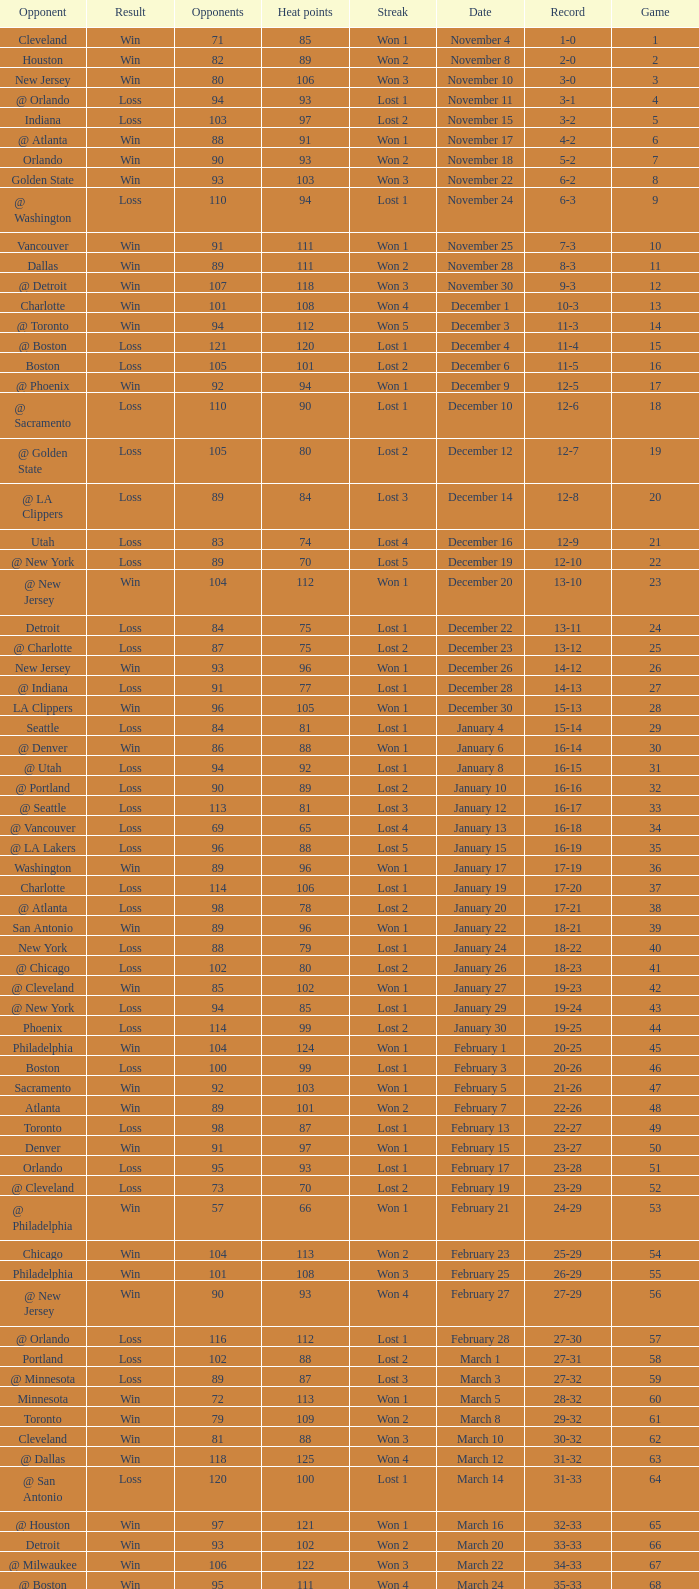What is Heat Points, when Game is less than 80, and when Date is "April 26 (First Round)"? 85.0. 